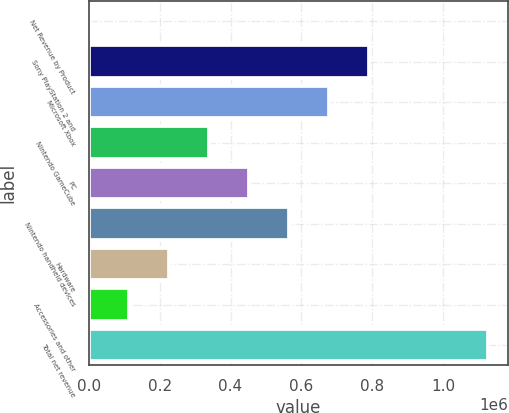Convert chart. <chart><loc_0><loc_0><loc_500><loc_500><bar_chart><fcel>Net Revenue by Product<fcel>Sony PlayStation 2 and<fcel>Microsoft Xbox<fcel>Nintendo GameCube<fcel>PC<fcel>Nintendo handheld devices<fcel>Hardware<fcel>Accessories and other<fcel>Total net revenue<nl><fcel>2004<fcel>790027<fcel>677452<fcel>339728<fcel>452303<fcel>564878<fcel>227153<fcel>114579<fcel>1.12775e+06<nl></chart> 